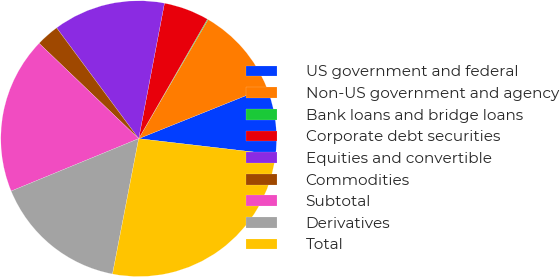Convert chart. <chart><loc_0><loc_0><loc_500><loc_500><pie_chart><fcel>US government and federal<fcel>Non-US government and agency<fcel>Bank loans and bridge loans<fcel>Corporate debt securities<fcel>Equities and convertible<fcel>Commodities<fcel>Subtotal<fcel>Derivatives<fcel>Total<nl><fcel>7.92%<fcel>10.53%<fcel>0.09%<fcel>5.31%<fcel>13.14%<fcel>2.7%<fcel>18.36%<fcel>15.75%<fcel>26.19%<nl></chart> 